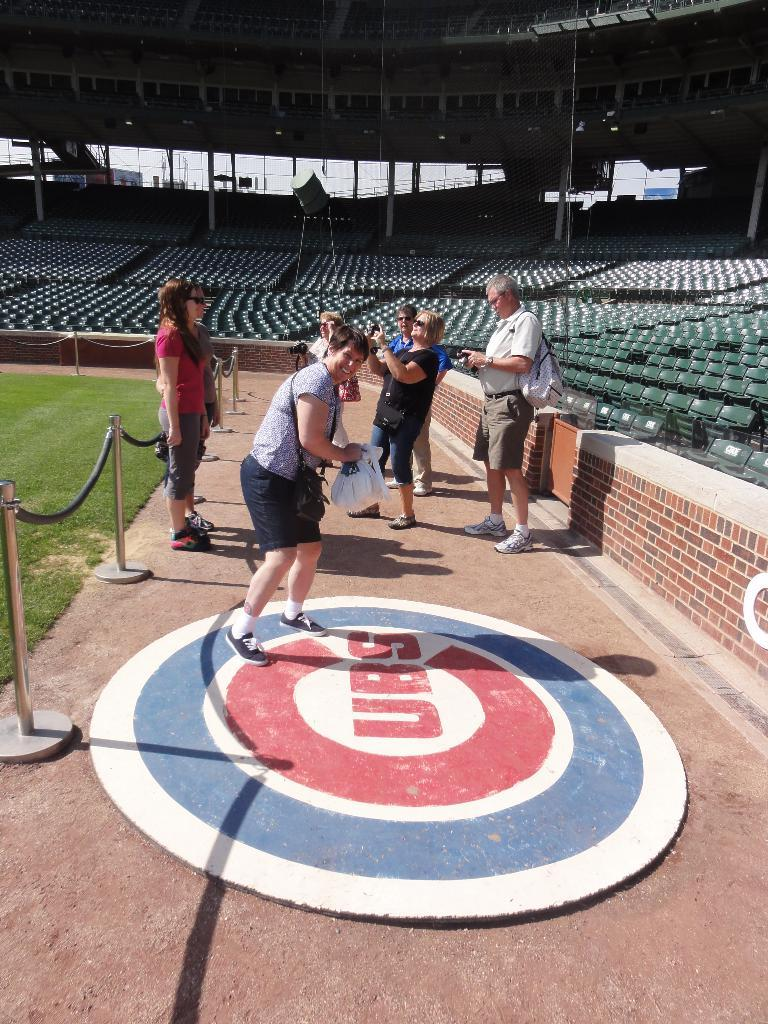What is the primary setting of the image? People are standing on the ground in the image. What type of vegetation is present in the image? Grass is present in the image. What structures can be seen in the image? Poles and walls are visible in the image. What type of furniture is present in the image? Chairs are visible in the image. What architectural features can be seen in the background of the image? In the background of the image, there are pillars and a roof, as well as a building. What other objects are present in the background of the image? Some objects are present in the background of the image. What type of beds can be seen in the image? There are no beds present in the image. What is the group of people eating for lunch in the image? There is no mention of lunch or a group of people eating in the image. 